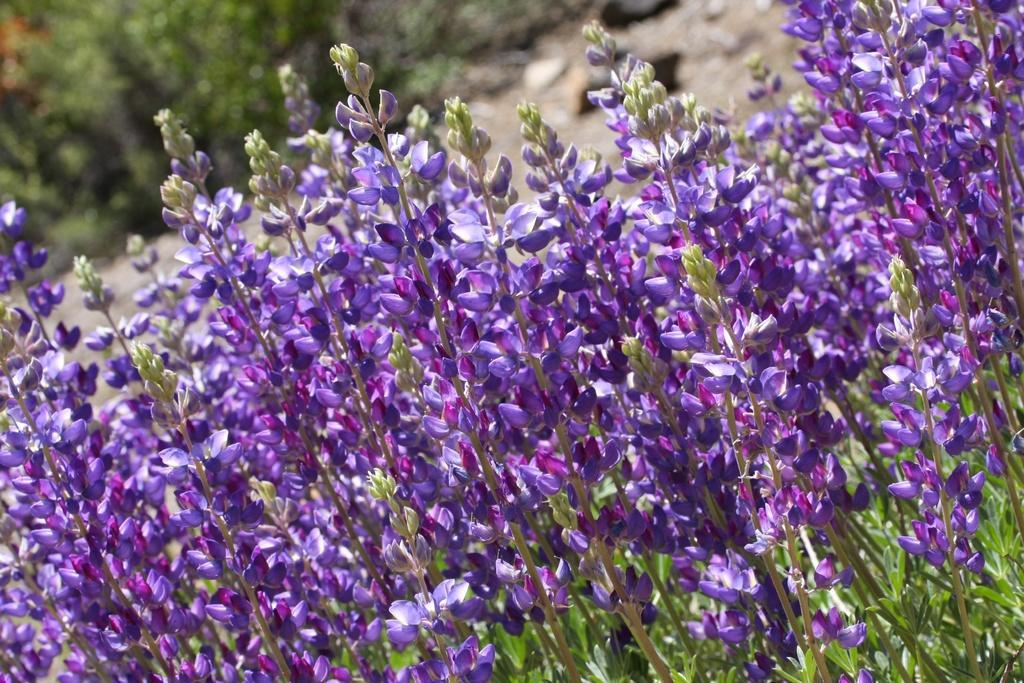In one or two sentences, can you explain what this image depicts? In the image there are stems with flowers and leaves. And there is a blur background. 